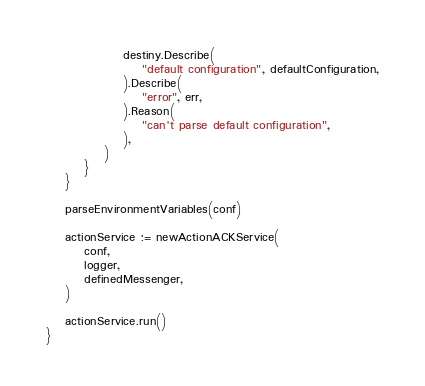Convert code to text. <code><loc_0><loc_0><loc_500><loc_500><_Go_>				destiny.Describe(
					"default configuration", defaultConfiguration,
				).Describe(
					"error", err,
				).Reason(
					"can't parse default configuration",
				),
			)
		}
	}

	parseEnvironmentVariables(conf)

	actionService := newActionACKService(
		conf,
		logger,
		definedMessenger,
	)

	actionService.run()
}
</code> 